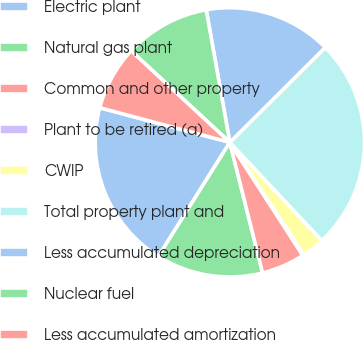Convert chart. <chart><loc_0><loc_0><loc_500><loc_500><pie_chart><fcel>Electric plant<fcel>Natural gas plant<fcel>Common and other property<fcel>Plant to be retired (a)<fcel>CWIP<fcel>Total property plant and<fcel>Less accumulated depreciation<fcel>Nuclear fuel<fcel>Less accumulated amortization<nl><fcel>20.23%<fcel>12.82%<fcel>5.22%<fcel>0.16%<fcel>2.69%<fcel>25.48%<fcel>15.35%<fcel>10.29%<fcel>7.76%<nl></chart> 